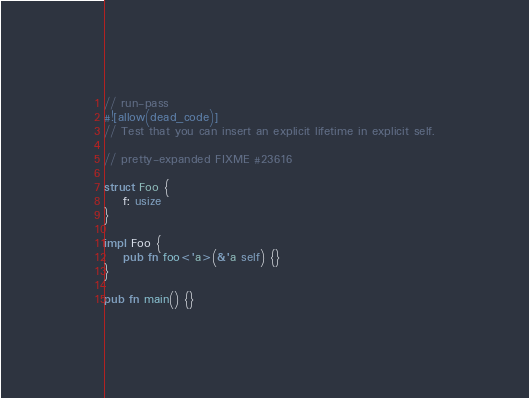Convert code to text. <code><loc_0><loc_0><loc_500><loc_500><_Rust_>// run-pass
#![allow(dead_code)]
// Test that you can insert an explicit lifetime in explicit self.

// pretty-expanded FIXME #23616

struct Foo {
    f: usize
}

impl Foo {
    pub fn foo<'a>(&'a self) {}
}

pub fn main() {}
</code> 